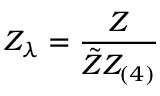<formula> <loc_0><loc_0><loc_500><loc_500>Z _ { \lambda } = \frac { Z } { \tilde { Z } Z _ { ( 4 ) } }</formula> 